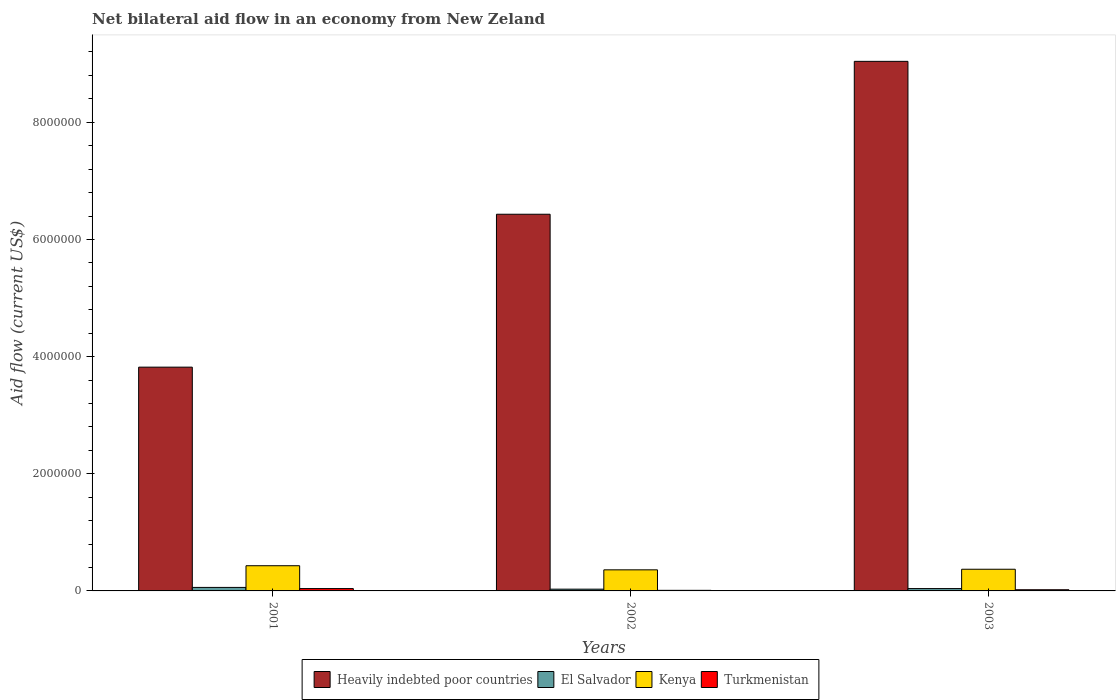How many groups of bars are there?
Your answer should be very brief. 3. How many bars are there on the 2nd tick from the right?
Provide a succinct answer. 4. In how many cases, is the number of bars for a given year not equal to the number of legend labels?
Ensure brevity in your answer.  0. What is the net bilateral aid flow in Turkmenistan in 2002?
Your response must be concise. 10000. Across all years, what is the maximum net bilateral aid flow in Kenya?
Ensure brevity in your answer.  4.30e+05. Across all years, what is the minimum net bilateral aid flow in El Salvador?
Your response must be concise. 3.00e+04. In which year was the net bilateral aid flow in Turkmenistan minimum?
Provide a succinct answer. 2002. What is the total net bilateral aid flow in Kenya in the graph?
Offer a terse response. 1.16e+06. What is the difference between the net bilateral aid flow in Turkmenistan in 2001 and that in 2002?
Your answer should be compact. 3.00e+04. What is the difference between the net bilateral aid flow in El Salvador in 2003 and the net bilateral aid flow in Heavily indebted poor countries in 2002?
Provide a succinct answer. -6.39e+06. What is the average net bilateral aid flow in Kenya per year?
Provide a short and direct response. 3.87e+05. In the year 2003, what is the difference between the net bilateral aid flow in Turkmenistan and net bilateral aid flow in Kenya?
Your answer should be very brief. -3.50e+05. What is the ratio of the net bilateral aid flow in Heavily indebted poor countries in 2002 to that in 2003?
Keep it short and to the point. 0.71. What is the difference between the highest and the second highest net bilateral aid flow in Heavily indebted poor countries?
Your answer should be compact. 2.61e+06. In how many years, is the net bilateral aid flow in Turkmenistan greater than the average net bilateral aid flow in Turkmenistan taken over all years?
Make the answer very short. 1. Is the sum of the net bilateral aid flow in Kenya in 2002 and 2003 greater than the maximum net bilateral aid flow in El Salvador across all years?
Offer a terse response. Yes. What does the 3rd bar from the left in 2003 represents?
Your answer should be compact. Kenya. What does the 2nd bar from the right in 2002 represents?
Ensure brevity in your answer.  Kenya. How many bars are there?
Ensure brevity in your answer.  12. How many years are there in the graph?
Provide a short and direct response. 3. Does the graph contain any zero values?
Your answer should be compact. No. Where does the legend appear in the graph?
Offer a very short reply. Bottom center. How many legend labels are there?
Your answer should be compact. 4. What is the title of the graph?
Keep it short and to the point. Net bilateral aid flow in an economy from New Zeland. What is the label or title of the X-axis?
Offer a terse response. Years. What is the label or title of the Y-axis?
Give a very brief answer. Aid flow (current US$). What is the Aid flow (current US$) in Heavily indebted poor countries in 2001?
Provide a short and direct response. 3.82e+06. What is the Aid flow (current US$) in Turkmenistan in 2001?
Provide a succinct answer. 4.00e+04. What is the Aid flow (current US$) in Heavily indebted poor countries in 2002?
Offer a very short reply. 6.43e+06. What is the Aid flow (current US$) in El Salvador in 2002?
Give a very brief answer. 3.00e+04. What is the Aid flow (current US$) of Heavily indebted poor countries in 2003?
Offer a terse response. 9.04e+06. What is the Aid flow (current US$) of El Salvador in 2003?
Keep it short and to the point. 4.00e+04. What is the Aid flow (current US$) of Kenya in 2003?
Keep it short and to the point. 3.70e+05. What is the Aid flow (current US$) of Turkmenistan in 2003?
Your answer should be very brief. 2.00e+04. Across all years, what is the maximum Aid flow (current US$) of Heavily indebted poor countries?
Offer a very short reply. 9.04e+06. Across all years, what is the maximum Aid flow (current US$) of El Salvador?
Your answer should be compact. 6.00e+04. Across all years, what is the maximum Aid flow (current US$) in Turkmenistan?
Your answer should be compact. 4.00e+04. Across all years, what is the minimum Aid flow (current US$) of Heavily indebted poor countries?
Provide a succinct answer. 3.82e+06. Across all years, what is the minimum Aid flow (current US$) in El Salvador?
Provide a short and direct response. 3.00e+04. Across all years, what is the minimum Aid flow (current US$) of Turkmenistan?
Offer a terse response. 10000. What is the total Aid flow (current US$) of Heavily indebted poor countries in the graph?
Provide a succinct answer. 1.93e+07. What is the total Aid flow (current US$) in El Salvador in the graph?
Provide a succinct answer. 1.30e+05. What is the total Aid flow (current US$) of Kenya in the graph?
Your answer should be very brief. 1.16e+06. What is the total Aid flow (current US$) in Turkmenistan in the graph?
Make the answer very short. 7.00e+04. What is the difference between the Aid flow (current US$) in Heavily indebted poor countries in 2001 and that in 2002?
Keep it short and to the point. -2.61e+06. What is the difference between the Aid flow (current US$) of El Salvador in 2001 and that in 2002?
Give a very brief answer. 3.00e+04. What is the difference between the Aid flow (current US$) in Turkmenistan in 2001 and that in 2002?
Provide a short and direct response. 3.00e+04. What is the difference between the Aid flow (current US$) of Heavily indebted poor countries in 2001 and that in 2003?
Keep it short and to the point. -5.22e+06. What is the difference between the Aid flow (current US$) in Turkmenistan in 2001 and that in 2003?
Keep it short and to the point. 2.00e+04. What is the difference between the Aid flow (current US$) in Heavily indebted poor countries in 2002 and that in 2003?
Offer a very short reply. -2.61e+06. What is the difference between the Aid flow (current US$) of Kenya in 2002 and that in 2003?
Offer a terse response. -10000. What is the difference between the Aid flow (current US$) in Turkmenistan in 2002 and that in 2003?
Provide a succinct answer. -10000. What is the difference between the Aid flow (current US$) in Heavily indebted poor countries in 2001 and the Aid flow (current US$) in El Salvador in 2002?
Keep it short and to the point. 3.79e+06. What is the difference between the Aid flow (current US$) of Heavily indebted poor countries in 2001 and the Aid flow (current US$) of Kenya in 2002?
Keep it short and to the point. 3.46e+06. What is the difference between the Aid flow (current US$) in Heavily indebted poor countries in 2001 and the Aid flow (current US$) in Turkmenistan in 2002?
Your answer should be very brief. 3.81e+06. What is the difference between the Aid flow (current US$) in El Salvador in 2001 and the Aid flow (current US$) in Kenya in 2002?
Offer a terse response. -3.00e+05. What is the difference between the Aid flow (current US$) of El Salvador in 2001 and the Aid flow (current US$) of Turkmenistan in 2002?
Keep it short and to the point. 5.00e+04. What is the difference between the Aid flow (current US$) in Kenya in 2001 and the Aid flow (current US$) in Turkmenistan in 2002?
Give a very brief answer. 4.20e+05. What is the difference between the Aid flow (current US$) in Heavily indebted poor countries in 2001 and the Aid flow (current US$) in El Salvador in 2003?
Ensure brevity in your answer.  3.78e+06. What is the difference between the Aid flow (current US$) of Heavily indebted poor countries in 2001 and the Aid flow (current US$) of Kenya in 2003?
Ensure brevity in your answer.  3.45e+06. What is the difference between the Aid flow (current US$) in Heavily indebted poor countries in 2001 and the Aid flow (current US$) in Turkmenistan in 2003?
Make the answer very short. 3.80e+06. What is the difference between the Aid flow (current US$) in El Salvador in 2001 and the Aid flow (current US$) in Kenya in 2003?
Your answer should be very brief. -3.10e+05. What is the difference between the Aid flow (current US$) of El Salvador in 2001 and the Aid flow (current US$) of Turkmenistan in 2003?
Offer a very short reply. 4.00e+04. What is the difference between the Aid flow (current US$) in Kenya in 2001 and the Aid flow (current US$) in Turkmenistan in 2003?
Your answer should be compact. 4.10e+05. What is the difference between the Aid flow (current US$) of Heavily indebted poor countries in 2002 and the Aid flow (current US$) of El Salvador in 2003?
Offer a very short reply. 6.39e+06. What is the difference between the Aid flow (current US$) of Heavily indebted poor countries in 2002 and the Aid flow (current US$) of Kenya in 2003?
Your answer should be compact. 6.06e+06. What is the difference between the Aid flow (current US$) in Heavily indebted poor countries in 2002 and the Aid flow (current US$) in Turkmenistan in 2003?
Offer a terse response. 6.41e+06. What is the difference between the Aid flow (current US$) in El Salvador in 2002 and the Aid flow (current US$) in Kenya in 2003?
Offer a very short reply. -3.40e+05. What is the difference between the Aid flow (current US$) in El Salvador in 2002 and the Aid flow (current US$) in Turkmenistan in 2003?
Ensure brevity in your answer.  10000. What is the difference between the Aid flow (current US$) in Kenya in 2002 and the Aid flow (current US$) in Turkmenistan in 2003?
Offer a terse response. 3.40e+05. What is the average Aid flow (current US$) of Heavily indebted poor countries per year?
Provide a short and direct response. 6.43e+06. What is the average Aid flow (current US$) of El Salvador per year?
Your answer should be compact. 4.33e+04. What is the average Aid flow (current US$) of Kenya per year?
Keep it short and to the point. 3.87e+05. What is the average Aid flow (current US$) in Turkmenistan per year?
Your answer should be compact. 2.33e+04. In the year 2001, what is the difference between the Aid flow (current US$) in Heavily indebted poor countries and Aid flow (current US$) in El Salvador?
Your answer should be compact. 3.76e+06. In the year 2001, what is the difference between the Aid flow (current US$) of Heavily indebted poor countries and Aid flow (current US$) of Kenya?
Offer a terse response. 3.39e+06. In the year 2001, what is the difference between the Aid flow (current US$) in Heavily indebted poor countries and Aid flow (current US$) in Turkmenistan?
Make the answer very short. 3.78e+06. In the year 2001, what is the difference between the Aid flow (current US$) in El Salvador and Aid flow (current US$) in Kenya?
Provide a short and direct response. -3.70e+05. In the year 2002, what is the difference between the Aid flow (current US$) of Heavily indebted poor countries and Aid flow (current US$) of El Salvador?
Make the answer very short. 6.40e+06. In the year 2002, what is the difference between the Aid flow (current US$) of Heavily indebted poor countries and Aid flow (current US$) of Kenya?
Your response must be concise. 6.07e+06. In the year 2002, what is the difference between the Aid flow (current US$) of Heavily indebted poor countries and Aid flow (current US$) of Turkmenistan?
Your answer should be very brief. 6.42e+06. In the year 2002, what is the difference between the Aid flow (current US$) of El Salvador and Aid flow (current US$) of Kenya?
Your answer should be compact. -3.30e+05. In the year 2003, what is the difference between the Aid flow (current US$) in Heavily indebted poor countries and Aid flow (current US$) in El Salvador?
Provide a succinct answer. 9.00e+06. In the year 2003, what is the difference between the Aid flow (current US$) of Heavily indebted poor countries and Aid flow (current US$) of Kenya?
Offer a very short reply. 8.67e+06. In the year 2003, what is the difference between the Aid flow (current US$) in Heavily indebted poor countries and Aid flow (current US$) in Turkmenistan?
Ensure brevity in your answer.  9.02e+06. In the year 2003, what is the difference between the Aid flow (current US$) in El Salvador and Aid flow (current US$) in Kenya?
Your answer should be compact. -3.30e+05. What is the ratio of the Aid flow (current US$) of Heavily indebted poor countries in 2001 to that in 2002?
Your response must be concise. 0.59. What is the ratio of the Aid flow (current US$) in El Salvador in 2001 to that in 2002?
Keep it short and to the point. 2. What is the ratio of the Aid flow (current US$) in Kenya in 2001 to that in 2002?
Your answer should be very brief. 1.19. What is the ratio of the Aid flow (current US$) of Turkmenistan in 2001 to that in 2002?
Give a very brief answer. 4. What is the ratio of the Aid flow (current US$) in Heavily indebted poor countries in 2001 to that in 2003?
Provide a succinct answer. 0.42. What is the ratio of the Aid flow (current US$) in El Salvador in 2001 to that in 2003?
Make the answer very short. 1.5. What is the ratio of the Aid flow (current US$) of Kenya in 2001 to that in 2003?
Keep it short and to the point. 1.16. What is the ratio of the Aid flow (current US$) of Turkmenistan in 2001 to that in 2003?
Ensure brevity in your answer.  2. What is the ratio of the Aid flow (current US$) in Heavily indebted poor countries in 2002 to that in 2003?
Provide a short and direct response. 0.71. What is the ratio of the Aid flow (current US$) of El Salvador in 2002 to that in 2003?
Your response must be concise. 0.75. What is the ratio of the Aid flow (current US$) in Kenya in 2002 to that in 2003?
Ensure brevity in your answer.  0.97. What is the difference between the highest and the second highest Aid flow (current US$) of Heavily indebted poor countries?
Offer a very short reply. 2.61e+06. What is the difference between the highest and the second highest Aid flow (current US$) of Turkmenistan?
Your answer should be very brief. 2.00e+04. What is the difference between the highest and the lowest Aid flow (current US$) in Heavily indebted poor countries?
Provide a succinct answer. 5.22e+06. What is the difference between the highest and the lowest Aid flow (current US$) of Kenya?
Your response must be concise. 7.00e+04. What is the difference between the highest and the lowest Aid flow (current US$) of Turkmenistan?
Provide a succinct answer. 3.00e+04. 